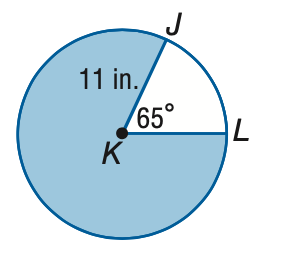Answer the mathemtical geometry problem and directly provide the correct option letter.
Question: Find the area of the shaded sector. Round to the nearest tenth.
Choices: A: 6.2 B: 12.5 C: 68.6 D: 311.5 D 